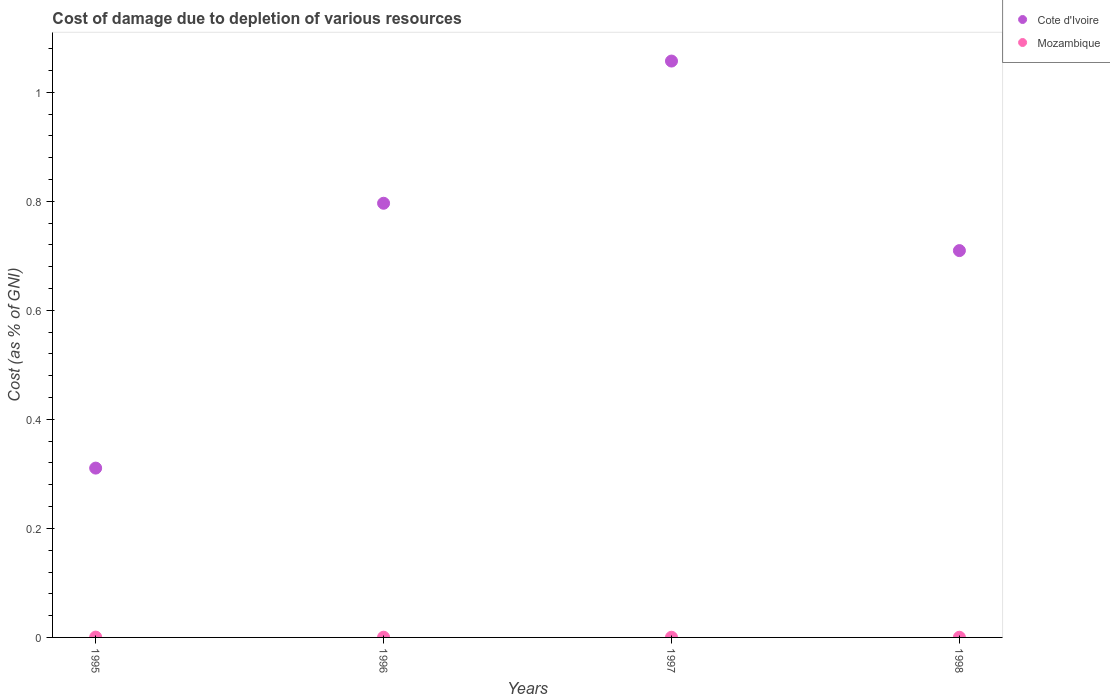How many different coloured dotlines are there?
Your response must be concise. 2. What is the cost of damage caused due to the depletion of various resources in Cote d'Ivoire in 1996?
Keep it short and to the point. 0.8. Across all years, what is the maximum cost of damage caused due to the depletion of various resources in Cote d'Ivoire?
Make the answer very short. 1.06. Across all years, what is the minimum cost of damage caused due to the depletion of various resources in Mozambique?
Offer a terse response. 0. In which year was the cost of damage caused due to the depletion of various resources in Mozambique minimum?
Offer a very short reply. 1998. What is the total cost of damage caused due to the depletion of various resources in Mozambique in the graph?
Make the answer very short. 0. What is the difference between the cost of damage caused due to the depletion of various resources in Mozambique in 1996 and that in 1997?
Your answer should be very brief. 4.0215124160649014e-5. What is the difference between the cost of damage caused due to the depletion of various resources in Mozambique in 1997 and the cost of damage caused due to the depletion of various resources in Cote d'Ivoire in 1996?
Offer a terse response. -0.8. What is the average cost of damage caused due to the depletion of various resources in Cote d'Ivoire per year?
Make the answer very short. 0.72. In the year 1995, what is the difference between the cost of damage caused due to the depletion of various resources in Cote d'Ivoire and cost of damage caused due to the depletion of various resources in Mozambique?
Keep it short and to the point. 0.31. What is the ratio of the cost of damage caused due to the depletion of various resources in Mozambique in 1995 to that in 1996?
Ensure brevity in your answer.  1.53. Is the difference between the cost of damage caused due to the depletion of various resources in Cote d'Ivoire in 1995 and 1997 greater than the difference between the cost of damage caused due to the depletion of various resources in Mozambique in 1995 and 1997?
Offer a terse response. No. What is the difference between the highest and the second highest cost of damage caused due to the depletion of various resources in Mozambique?
Provide a short and direct response. 0. What is the difference between the highest and the lowest cost of damage caused due to the depletion of various resources in Cote d'Ivoire?
Offer a very short reply. 0.75. In how many years, is the cost of damage caused due to the depletion of various resources in Cote d'Ivoire greater than the average cost of damage caused due to the depletion of various resources in Cote d'Ivoire taken over all years?
Provide a short and direct response. 2. Does the cost of damage caused due to the depletion of various resources in Mozambique monotonically increase over the years?
Offer a terse response. No. Is the cost of damage caused due to the depletion of various resources in Cote d'Ivoire strictly less than the cost of damage caused due to the depletion of various resources in Mozambique over the years?
Your response must be concise. No. How many dotlines are there?
Ensure brevity in your answer.  2. Are the values on the major ticks of Y-axis written in scientific E-notation?
Make the answer very short. No. How many legend labels are there?
Provide a succinct answer. 2. How are the legend labels stacked?
Your answer should be very brief. Vertical. What is the title of the graph?
Offer a very short reply. Cost of damage due to depletion of various resources. Does "Cyprus" appear as one of the legend labels in the graph?
Ensure brevity in your answer.  No. What is the label or title of the X-axis?
Provide a succinct answer. Years. What is the label or title of the Y-axis?
Provide a succinct answer. Cost (as % of GNI). What is the Cost (as % of GNI) of Cote d'Ivoire in 1995?
Provide a succinct answer. 0.31. What is the Cost (as % of GNI) in Mozambique in 1995?
Keep it short and to the point. 0. What is the Cost (as % of GNI) in Cote d'Ivoire in 1996?
Provide a short and direct response. 0.8. What is the Cost (as % of GNI) in Mozambique in 1996?
Your answer should be compact. 0. What is the Cost (as % of GNI) of Cote d'Ivoire in 1997?
Offer a terse response. 1.06. What is the Cost (as % of GNI) of Mozambique in 1997?
Your answer should be very brief. 0. What is the Cost (as % of GNI) in Cote d'Ivoire in 1998?
Your response must be concise. 0.71. What is the Cost (as % of GNI) in Mozambique in 1998?
Ensure brevity in your answer.  0. Across all years, what is the maximum Cost (as % of GNI) in Cote d'Ivoire?
Your response must be concise. 1.06. Across all years, what is the maximum Cost (as % of GNI) of Mozambique?
Your answer should be compact. 0. Across all years, what is the minimum Cost (as % of GNI) in Cote d'Ivoire?
Your response must be concise. 0.31. Across all years, what is the minimum Cost (as % of GNI) of Mozambique?
Ensure brevity in your answer.  0. What is the total Cost (as % of GNI) of Cote d'Ivoire in the graph?
Offer a very short reply. 2.87. What is the total Cost (as % of GNI) in Mozambique in the graph?
Give a very brief answer. 0. What is the difference between the Cost (as % of GNI) in Cote d'Ivoire in 1995 and that in 1996?
Your response must be concise. -0.49. What is the difference between the Cost (as % of GNI) in Cote d'Ivoire in 1995 and that in 1997?
Offer a very short reply. -0.75. What is the difference between the Cost (as % of GNI) in Mozambique in 1995 and that in 1997?
Keep it short and to the point. 0. What is the difference between the Cost (as % of GNI) of Cote d'Ivoire in 1995 and that in 1998?
Keep it short and to the point. -0.4. What is the difference between the Cost (as % of GNI) in Cote d'Ivoire in 1996 and that in 1997?
Your response must be concise. -0.26. What is the difference between the Cost (as % of GNI) in Mozambique in 1996 and that in 1997?
Ensure brevity in your answer.  0. What is the difference between the Cost (as % of GNI) in Cote d'Ivoire in 1996 and that in 1998?
Provide a short and direct response. 0.09. What is the difference between the Cost (as % of GNI) in Cote d'Ivoire in 1997 and that in 1998?
Ensure brevity in your answer.  0.35. What is the difference between the Cost (as % of GNI) in Cote d'Ivoire in 1995 and the Cost (as % of GNI) in Mozambique in 1996?
Your response must be concise. 0.31. What is the difference between the Cost (as % of GNI) in Cote d'Ivoire in 1995 and the Cost (as % of GNI) in Mozambique in 1997?
Provide a succinct answer. 0.31. What is the difference between the Cost (as % of GNI) of Cote d'Ivoire in 1995 and the Cost (as % of GNI) of Mozambique in 1998?
Your answer should be very brief. 0.31. What is the difference between the Cost (as % of GNI) in Cote d'Ivoire in 1996 and the Cost (as % of GNI) in Mozambique in 1997?
Give a very brief answer. 0.8. What is the difference between the Cost (as % of GNI) of Cote d'Ivoire in 1996 and the Cost (as % of GNI) of Mozambique in 1998?
Make the answer very short. 0.8. What is the difference between the Cost (as % of GNI) of Cote d'Ivoire in 1997 and the Cost (as % of GNI) of Mozambique in 1998?
Ensure brevity in your answer.  1.06. What is the average Cost (as % of GNI) in Cote d'Ivoire per year?
Provide a succinct answer. 0.72. What is the average Cost (as % of GNI) of Mozambique per year?
Your answer should be very brief. 0. In the year 1995, what is the difference between the Cost (as % of GNI) in Cote d'Ivoire and Cost (as % of GNI) in Mozambique?
Provide a succinct answer. 0.31. In the year 1996, what is the difference between the Cost (as % of GNI) in Cote d'Ivoire and Cost (as % of GNI) in Mozambique?
Your answer should be very brief. 0.8. In the year 1997, what is the difference between the Cost (as % of GNI) of Cote d'Ivoire and Cost (as % of GNI) of Mozambique?
Give a very brief answer. 1.06. In the year 1998, what is the difference between the Cost (as % of GNI) in Cote d'Ivoire and Cost (as % of GNI) in Mozambique?
Provide a short and direct response. 0.71. What is the ratio of the Cost (as % of GNI) in Cote d'Ivoire in 1995 to that in 1996?
Offer a very short reply. 0.39. What is the ratio of the Cost (as % of GNI) of Mozambique in 1995 to that in 1996?
Make the answer very short. 1.53. What is the ratio of the Cost (as % of GNI) of Cote d'Ivoire in 1995 to that in 1997?
Offer a very short reply. 0.29. What is the ratio of the Cost (as % of GNI) in Mozambique in 1995 to that in 1997?
Provide a short and direct response. 1.7. What is the ratio of the Cost (as % of GNI) of Cote d'Ivoire in 1995 to that in 1998?
Your answer should be compact. 0.44. What is the ratio of the Cost (as % of GNI) in Mozambique in 1995 to that in 1998?
Give a very brief answer. 1.74. What is the ratio of the Cost (as % of GNI) of Cote d'Ivoire in 1996 to that in 1997?
Provide a succinct answer. 0.75. What is the ratio of the Cost (as % of GNI) in Mozambique in 1996 to that in 1997?
Give a very brief answer. 1.11. What is the ratio of the Cost (as % of GNI) in Cote d'Ivoire in 1996 to that in 1998?
Offer a terse response. 1.12. What is the ratio of the Cost (as % of GNI) of Mozambique in 1996 to that in 1998?
Provide a short and direct response. 1.14. What is the ratio of the Cost (as % of GNI) in Cote d'Ivoire in 1997 to that in 1998?
Provide a succinct answer. 1.49. What is the ratio of the Cost (as % of GNI) of Mozambique in 1997 to that in 1998?
Your answer should be very brief. 1.02. What is the difference between the highest and the second highest Cost (as % of GNI) in Cote d'Ivoire?
Your answer should be very brief. 0.26. What is the difference between the highest and the lowest Cost (as % of GNI) of Cote d'Ivoire?
Offer a very short reply. 0.75. What is the difference between the highest and the lowest Cost (as % of GNI) of Mozambique?
Offer a very short reply. 0. 